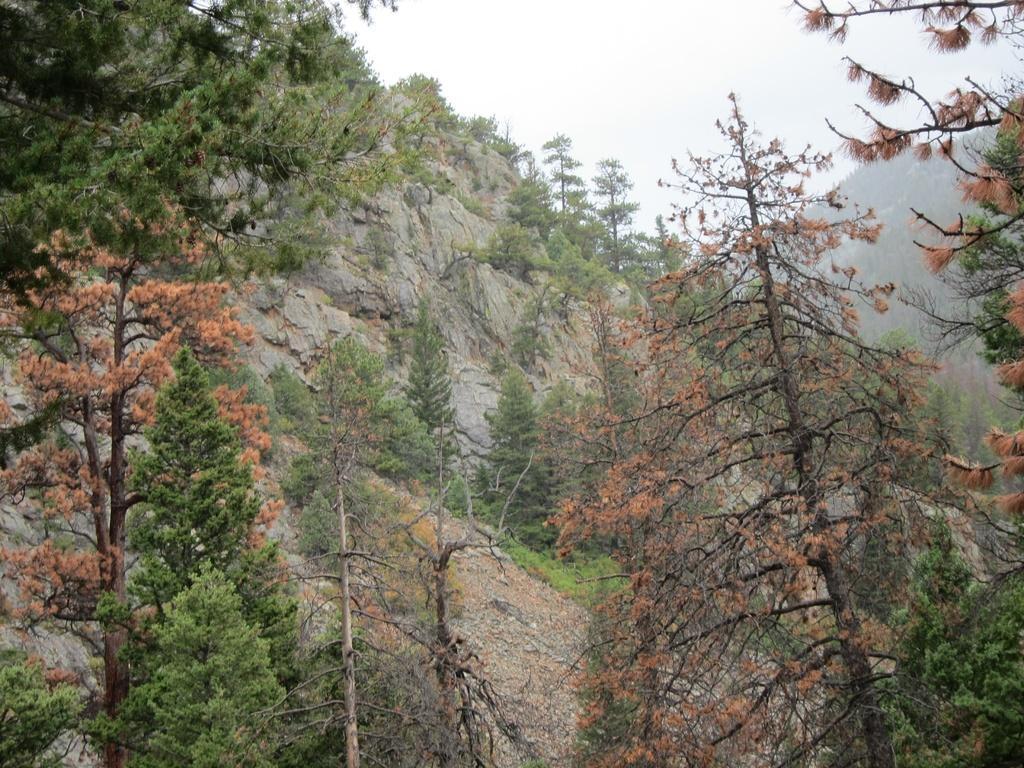Can you describe this image briefly? In the picture I can see the hills and trees. There are clouds in the sky. 